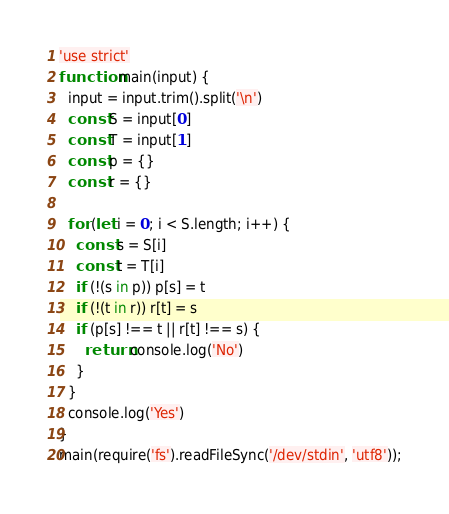<code> <loc_0><loc_0><loc_500><loc_500><_JavaScript_>'use strict'
function main(input) {
  input = input.trim().split('\n')
  const S = input[0]
  const T = input[1]
  const p = {}
  const r = {}

  for (let i = 0; i < S.length; i++) {
    const s = S[i]
    const t = T[i]
    if (!(s in p)) p[s] = t
    if (!(t in r)) r[t] = s
    if (p[s] !== t || r[t] !== s) {
      return console.log('No')
    }
  }
  console.log('Yes')
}
main(require('fs').readFileSync('/dev/stdin', 'utf8'));
</code> 